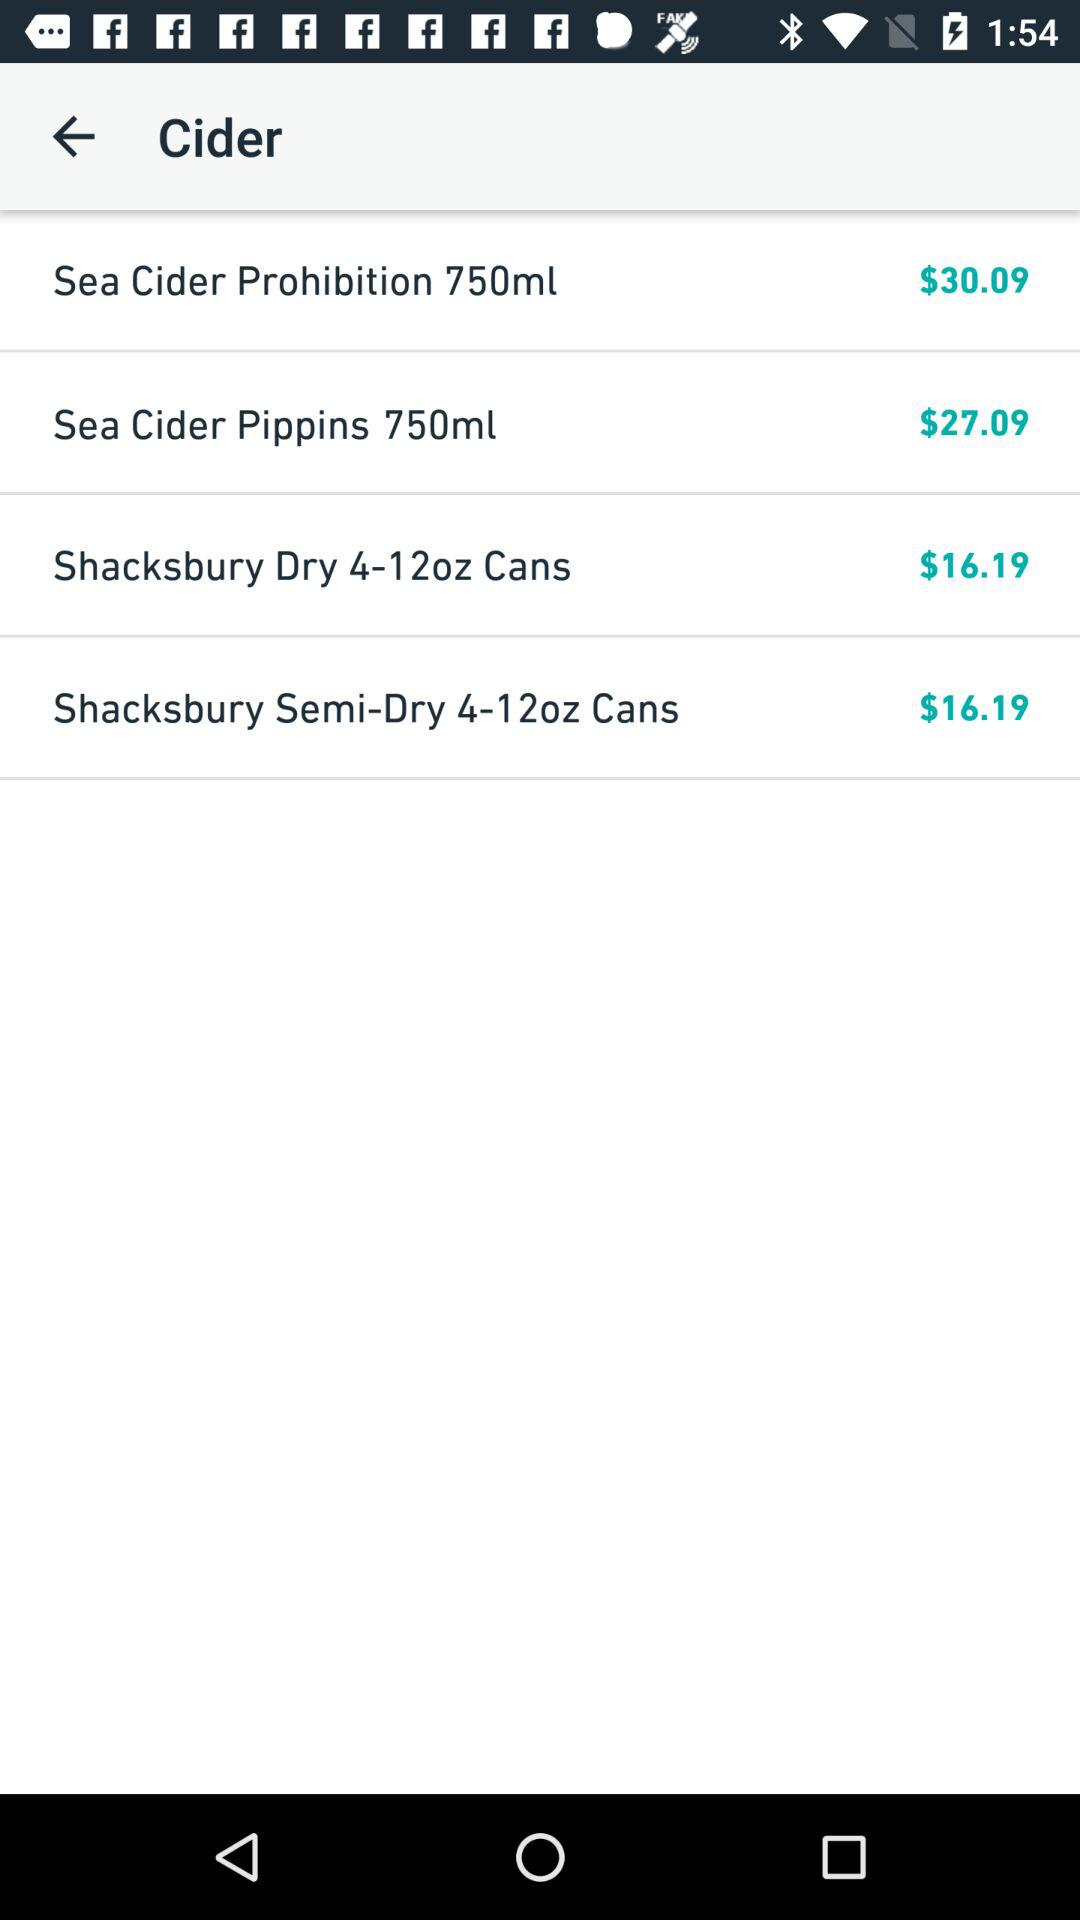How many items are more expensive than $20?
Answer the question using a single word or phrase. 2 